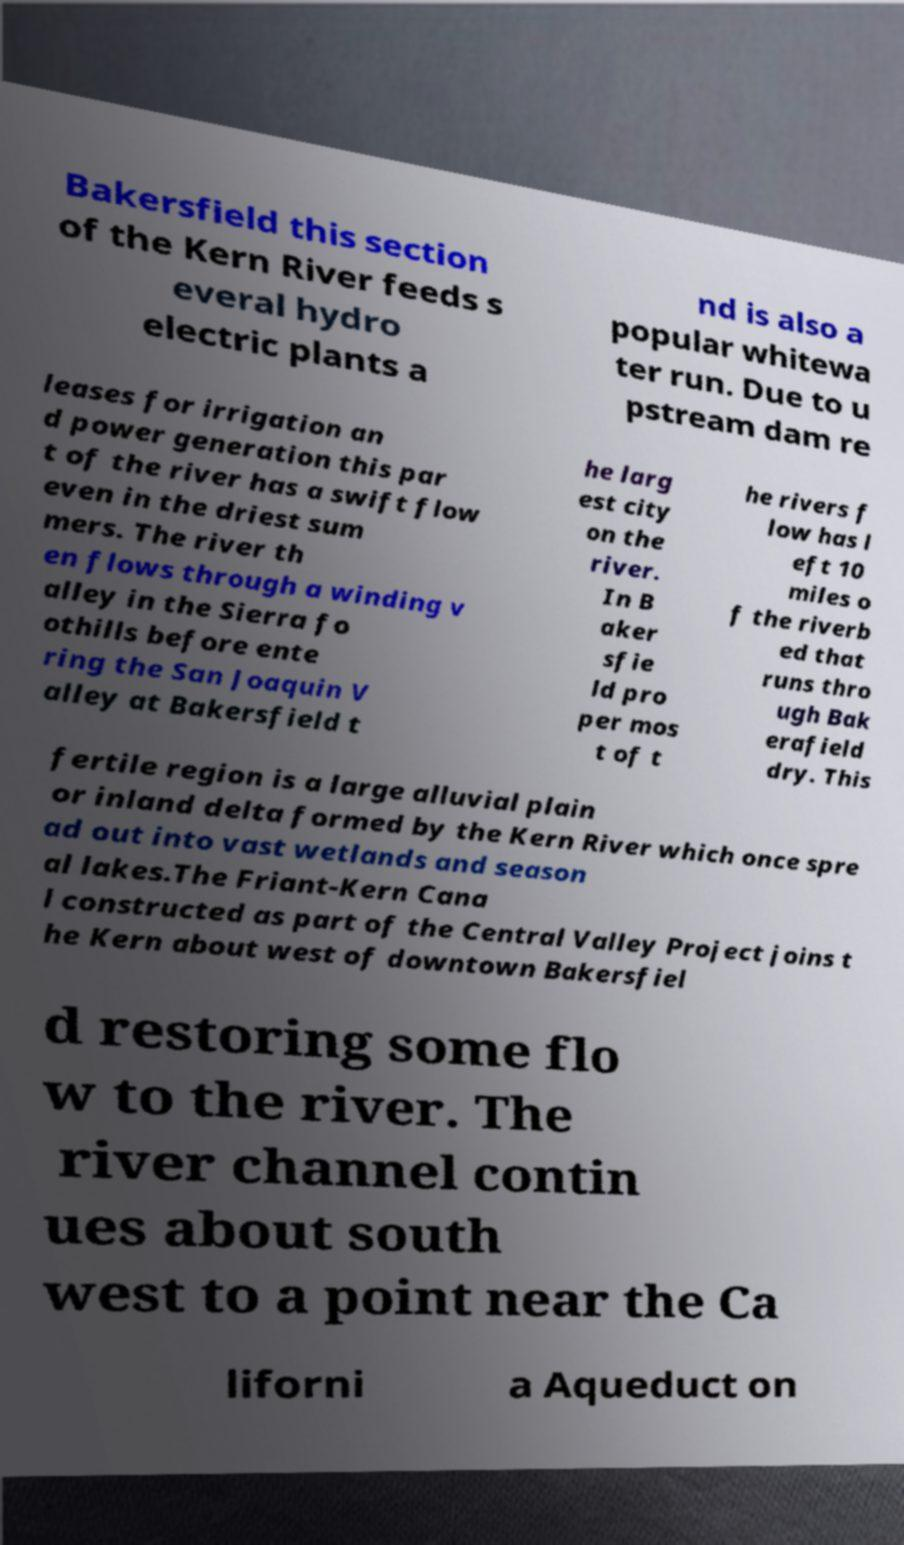Please read and relay the text visible in this image. What does it say? Bakersfield this section of the Kern River feeds s everal hydro electric plants a nd is also a popular whitewa ter run. Due to u pstream dam re leases for irrigation an d power generation this par t of the river has a swift flow even in the driest sum mers. The river th en flows through a winding v alley in the Sierra fo othills before ente ring the San Joaquin V alley at Bakersfield t he larg est city on the river. In B aker sfie ld pro per mos t of t he rivers f low has l eft 10 miles o f the riverb ed that runs thro ugh Bak erafield dry. This fertile region is a large alluvial plain or inland delta formed by the Kern River which once spre ad out into vast wetlands and season al lakes.The Friant-Kern Cana l constructed as part of the Central Valley Project joins t he Kern about west of downtown Bakersfiel d restoring some flo w to the river. The river channel contin ues about south west to a point near the Ca liforni a Aqueduct on 